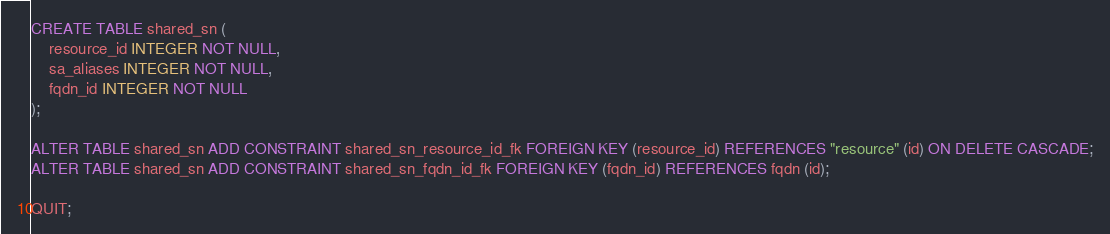Convert code to text. <code><loc_0><loc_0><loc_500><loc_500><_SQL_>CREATE TABLE shared_sn (
	resource_id INTEGER NOT NULL,
	sa_aliases INTEGER NOT NULL,
	fqdn_id INTEGER NOT NULL
);

ALTER TABLE shared_sn ADD CONSTRAINT shared_sn_resource_id_fk FOREIGN KEY (resource_id) REFERENCES "resource" (id) ON DELETE CASCADE;
ALTER TABLE shared_sn ADD CONSTRAINT shared_sn_fqdn_id_fk FOREIGN KEY (fqdn_id) REFERENCES fqdn (id);

QUIT;
</code> 